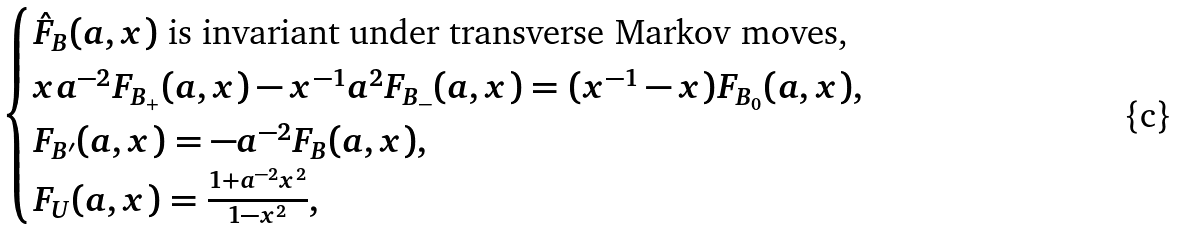Convert formula to latex. <formula><loc_0><loc_0><loc_500><loc_500>\begin{cases} \hat { F } _ { B } ( a , x ) \text { is invariant under transverse Markov moves,} \\ x a ^ { - 2 } F _ { B _ { + } } ( a , x ) - x ^ { - 1 } a ^ { 2 } F _ { B _ { - } } ( a , x ) = ( x ^ { - 1 } - x ) F _ { B _ { 0 } } ( a , x ) , \\ F _ { B ^ { \prime } } ( a , x ) = - a ^ { - 2 } F _ { B } ( a , x ) , \\ F _ { U } ( a , x ) = \frac { 1 + a ^ { - 2 } x ^ { 2 } } { 1 - x ^ { 2 } } , \end{cases}</formula> 